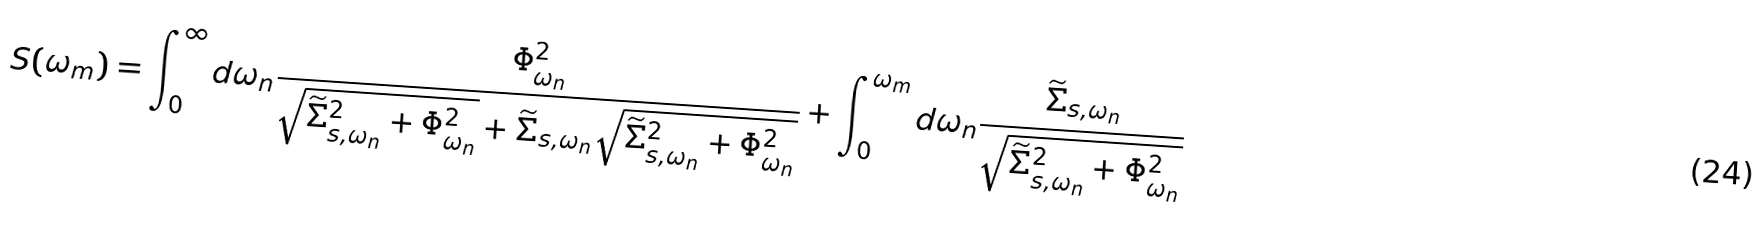<formula> <loc_0><loc_0><loc_500><loc_500>S ( \omega _ { m } ) = \int _ { 0 } ^ { \infty } d \omega _ { n } \frac { \Phi ^ { 2 } _ { \omega _ { n } } } { \sqrt { \widetilde { \Sigma } ^ { 2 } _ { s , \omega _ { n } } + \Phi ^ { 2 } _ { \omega _ { n } } } + { \widetilde { \Sigma } } _ { s , \omega _ { n } } \sqrt { \widetilde { \Sigma } ^ { 2 } _ { s , \omega _ { n } } + \Phi ^ { 2 } _ { \omega _ { n } } } } + \int _ { 0 } ^ { \omega _ { m } } d \omega _ { n } \frac { { \widetilde { \Sigma } } _ { s , \omega _ { n } } } { \sqrt { \widetilde { \Sigma } ^ { 2 } _ { s , \omega _ { n } } + \Phi ^ { 2 } _ { \omega _ { n } } } }</formula> 